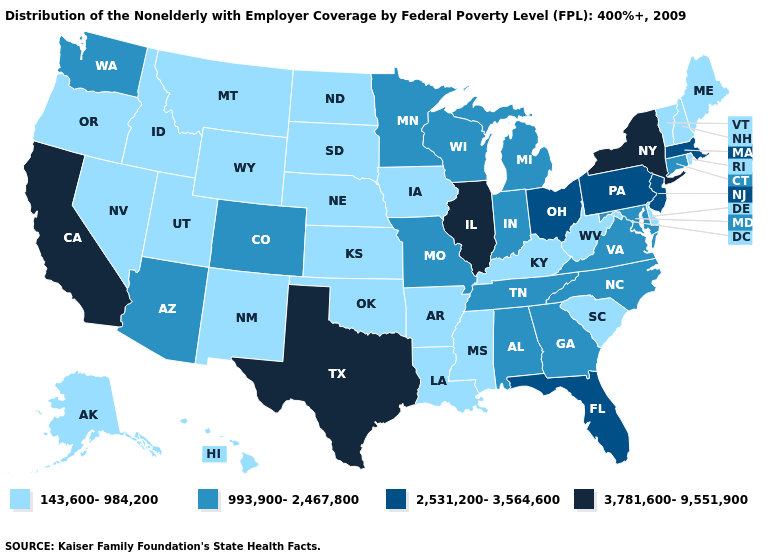Which states have the lowest value in the USA?
Write a very short answer. Alaska, Arkansas, Delaware, Hawaii, Idaho, Iowa, Kansas, Kentucky, Louisiana, Maine, Mississippi, Montana, Nebraska, Nevada, New Hampshire, New Mexico, North Dakota, Oklahoma, Oregon, Rhode Island, South Carolina, South Dakota, Utah, Vermont, West Virginia, Wyoming. What is the value of New Jersey?
Quick response, please. 2,531,200-3,564,600. What is the value of Virginia?
Concise answer only. 993,900-2,467,800. Name the states that have a value in the range 993,900-2,467,800?
Write a very short answer. Alabama, Arizona, Colorado, Connecticut, Georgia, Indiana, Maryland, Michigan, Minnesota, Missouri, North Carolina, Tennessee, Virginia, Washington, Wisconsin. Name the states that have a value in the range 993,900-2,467,800?
Write a very short answer. Alabama, Arizona, Colorado, Connecticut, Georgia, Indiana, Maryland, Michigan, Minnesota, Missouri, North Carolina, Tennessee, Virginia, Washington, Wisconsin. What is the highest value in the USA?
Be succinct. 3,781,600-9,551,900. What is the lowest value in the MidWest?
Be succinct. 143,600-984,200. What is the value of South Carolina?
Quick response, please. 143,600-984,200. Does the first symbol in the legend represent the smallest category?
Quick response, please. Yes. What is the lowest value in the West?
Be succinct. 143,600-984,200. Which states hav the highest value in the South?
Short answer required. Texas. What is the value of Missouri?
Be succinct. 993,900-2,467,800. What is the lowest value in the USA?
Quick response, please. 143,600-984,200. What is the lowest value in the USA?
Answer briefly. 143,600-984,200. 